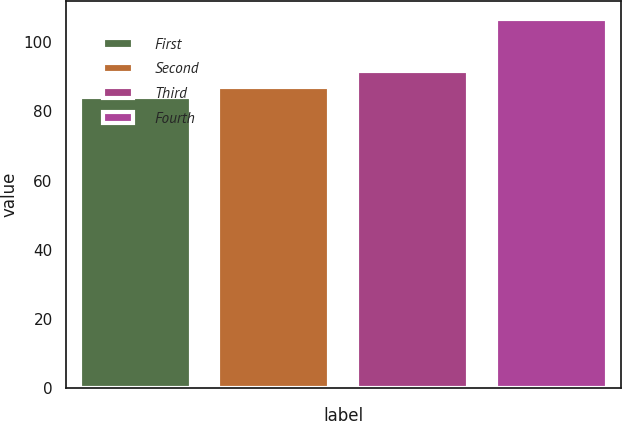Convert chart to OTSL. <chart><loc_0><loc_0><loc_500><loc_500><bar_chart><fcel>First<fcel>Second<fcel>Third<fcel>Fourth<nl><fcel>84.02<fcel>87.12<fcel>91.57<fcel>106.57<nl></chart> 